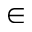<formula> <loc_0><loc_0><loc_500><loc_500>\in</formula> 